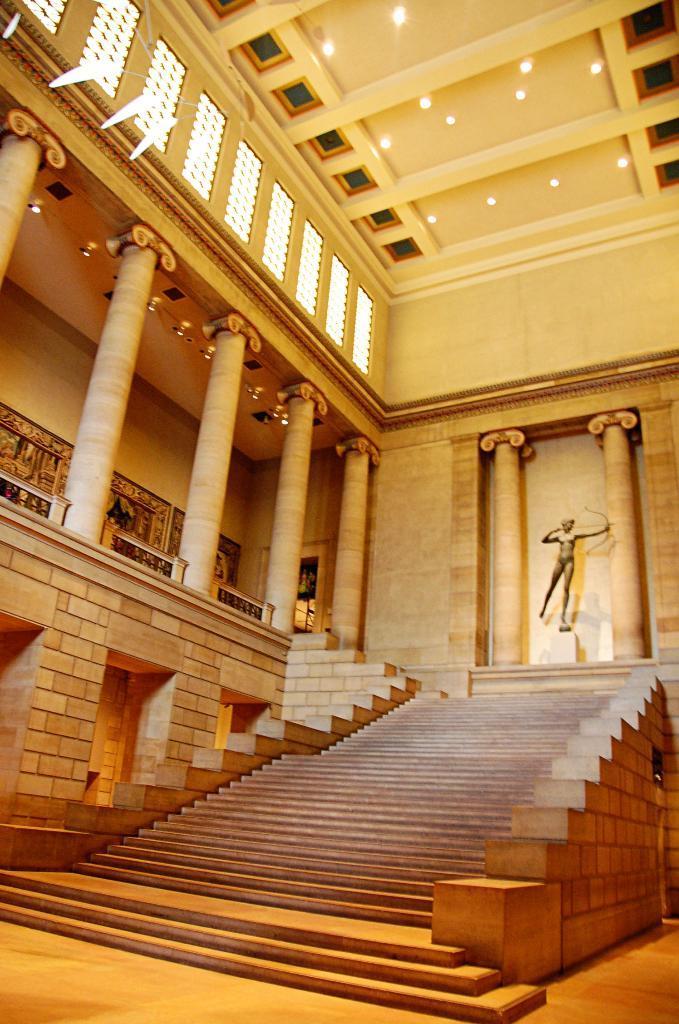How would you summarize this image in a sentence or two? In this image, in the middle, we can see a staircase. On the left side of the image, we can see some pillars. In the background, we can see some sculptures. At the top of the image, we can see a roof with few lights. 